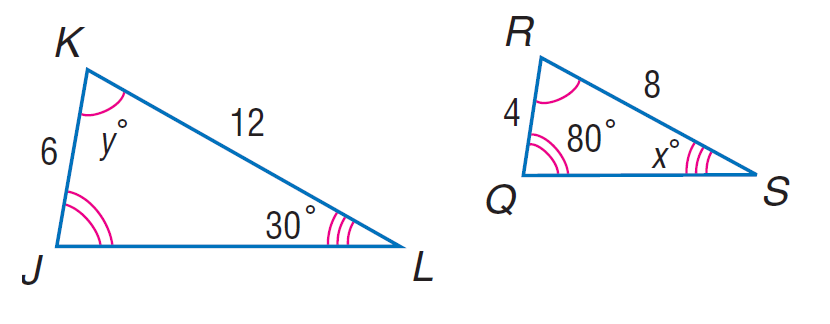Answer the mathemtical geometry problem and directly provide the correct option letter.
Question: Each pair of polygons is similar. Find y.
Choices: A: 70 B: 80 C: 100 D: 150 A 